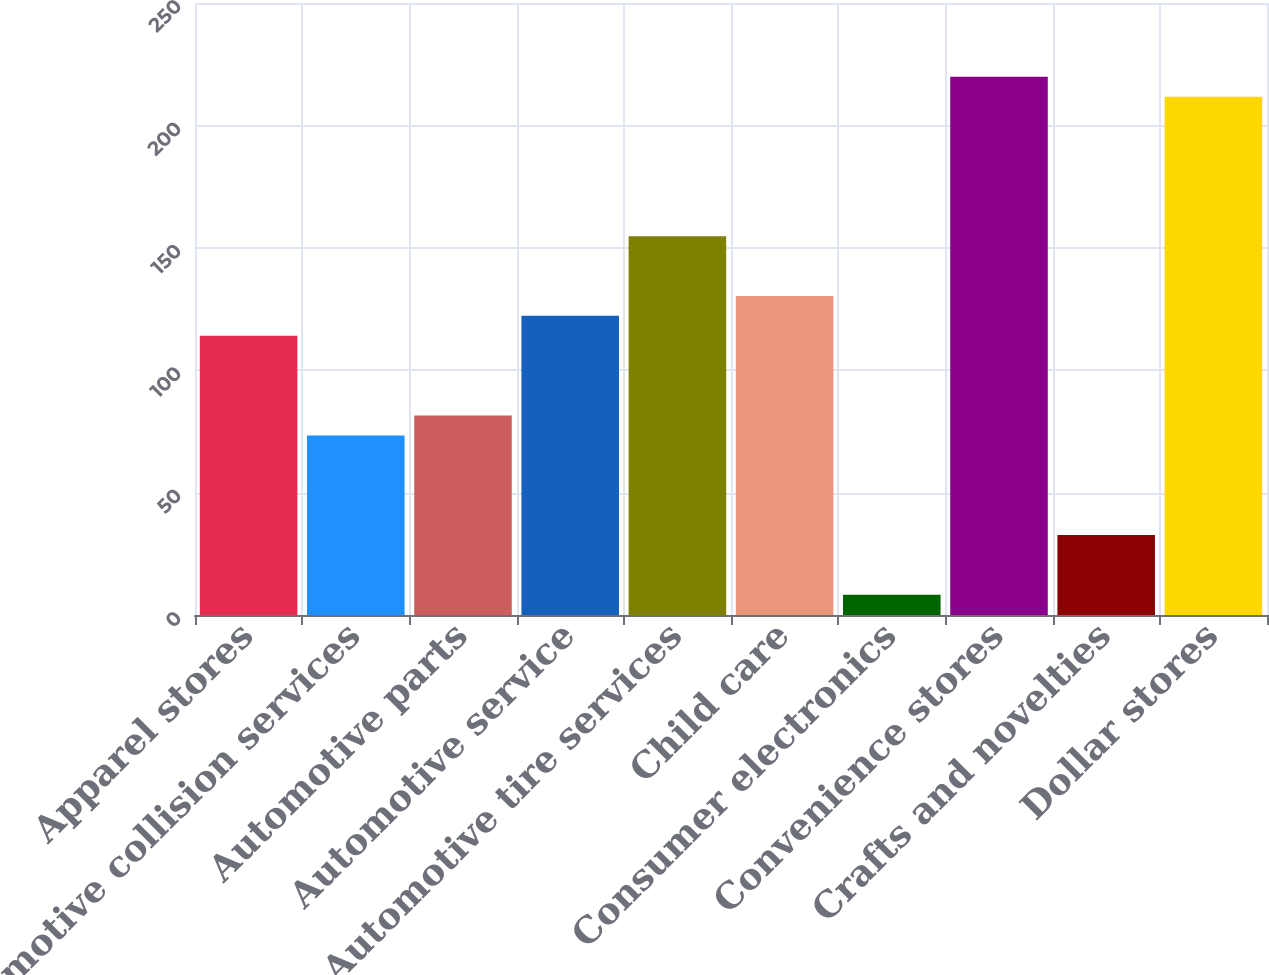Convert chart to OTSL. <chart><loc_0><loc_0><loc_500><loc_500><bar_chart><fcel>Apparel stores<fcel>Automotive collision services<fcel>Automotive parts<fcel>Automotive service<fcel>Automotive tire services<fcel>Child care<fcel>Consumer electronics<fcel>Convenience stores<fcel>Crafts and novelties<fcel>Dollar stores<nl><fcel>114.06<fcel>73.36<fcel>81.5<fcel>122.2<fcel>154.76<fcel>130.34<fcel>8.24<fcel>219.88<fcel>32.66<fcel>211.74<nl></chart> 